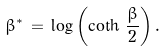Convert formula to latex. <formula><loc_0><loc_0><loc_500><loc_500>\beta ^ { * } \, = \, \log \left ( \coth \, \frac { \beta } { 2 } \right ) .</formula> 